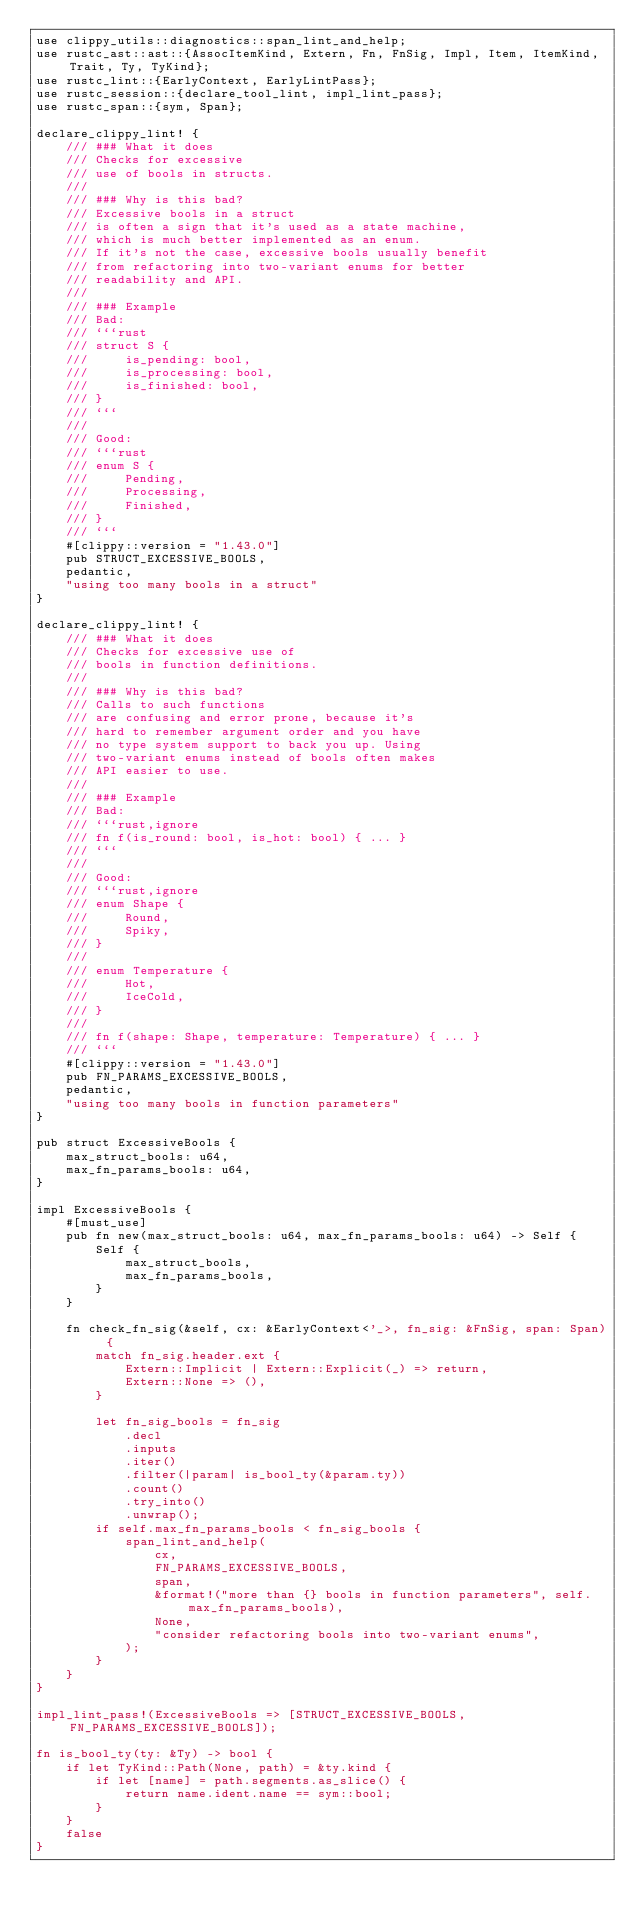Convert code to text. <code><loc_0><loc_0><loc_500><loc_500><_Rust_>use clippy_utils::diagnostics::span_lint_and_help;
use rustc_ast::ast::{AssocItemKind, Extern, Fn, FnSig, Impl, Item, ItemKind, Trait, Ty, TyKind};
use rustc_lint::{EarlyContext, EarlyLintPass};
use rustc_session::{declare_tool_lint, impl_lint_pass};
use rustc_span::{sym, Span};

declare_clippy_lint! {
    /// ### What it does
    /// Checks for excessive
    /// use of bools in structs.
    ///
    /// ### Why is this bad?
    /// Excessive bools in a struct
    /// is often a sign that it's used as a state machine,
    /// which is much better implemented as an enum.
    /// If it's not the case, excessive bools usually benefit
    /// from refactoring into two-variant enums for better
    /// readability and API.
    ///
    /// ### Example
    /// Bad:
    /// ```rust
    /// struct S {
    ///     is_pending: bool,
    ///     is_processing: bool,
    ///     is_finished: bool,
    /// }
    /// ```
    ///
    /// Good:
    /// ```rust
    /// enum S {
    ///     Pending,
    ///     Processing,
    ///     Finished,
    /// }
    /// ```
    #[clippy::version = "1.43.0"]
    pub STRUCT_EXCESSIVE_BOOLS,
    pedantic,
    "using too many bools in a struct"
}

declare_clippy_lint! {
    /// ### What it does
    /// Checks for excessive use of
    /// bools in function definitions.
    ///
    /// ### Why is this bad?
    /// Calls to such functions
    /// are confusing and error prone, because it's
    /// hard to remember argument order and you have
    /// no type system support to back you up. Using
    /// two-variant enums instead of bools often makes
    /// API easier to use.
    ///
    /// ### Example
    /// Bad:
    /// ```rust,ignore
    /// fn f(is_round: bool, is_hot: bool) { ... }
    /// ```
    ///
    /// Good:
    /// ```rust,ignore
    /// enum Shape {
    ///     Round,
    ///     Spiky,
    /// }
    ///
    /// enum Temperature {
    ///     Hot,
    ///     IceCold,
    /// }
    ///
    /// fn f(shape: Shape, temperature: Temperature) { ... }
    /// ```
    #[clippy::version = "1.43.0"]
    pub FN_PARAMS_EXCESSIVE_BOOLS,
    pedantic,
    "using too many bools in function parameters"
}

pub struct ExcessiveBools {
    max_struct_bools: u64,
    max_fn_params_bools: u64,
}

impl ExcessiveBools {
    #[must_use]
    pub fn new(max_struct_bools: u64, max_fn_params_bools: u64) -> Self {
        Self {
            max_struct_bools,
            max_fn_params_bools,
        }
    }

    fn check_fn_sig(&self, cx: &EarlyContext<'_>, fn_sig: &FnSig, span: Span) {
        match fn_sig.header.ext {
            Extern::Implicit | Extern::Explicit(_) => return,
            Extern::None => (),
        }

        let fn_sig_bools = fn_sig
            .decl
            .inputs
            .iter()
            .filter(|param| is_bool_ty(&param.ty))
            .count()
            .try_into()
            .unwrap();
        if self.max_fn_params_bools < fn_sig_bools {
            span_lint_and_help(
                cx,
                FN_PARAMS_EXCESSIVE_BOOLS,
                span,
                &format!("more than {} bools in function parameters", self.max_fn_params_bools),
                None,
                "consider refactoring bools into two-variant enums",
            );
        }
    }
}

impl_lint_pass!(ExcessiveBools => [STRUCT_EXCESSIVE_BOOLS, FN_PARAMS_EXCESSIVE_BOOLS]);

fn is_bool_ty(ty: &Ty) -> bool {
    if let TyKind::Path(None, path) = &ty.kind {
        if let [name] = path.segments.as_slice() {
            return name.ident.name == sym::bool;
        }
    }
    false
}
</code> 